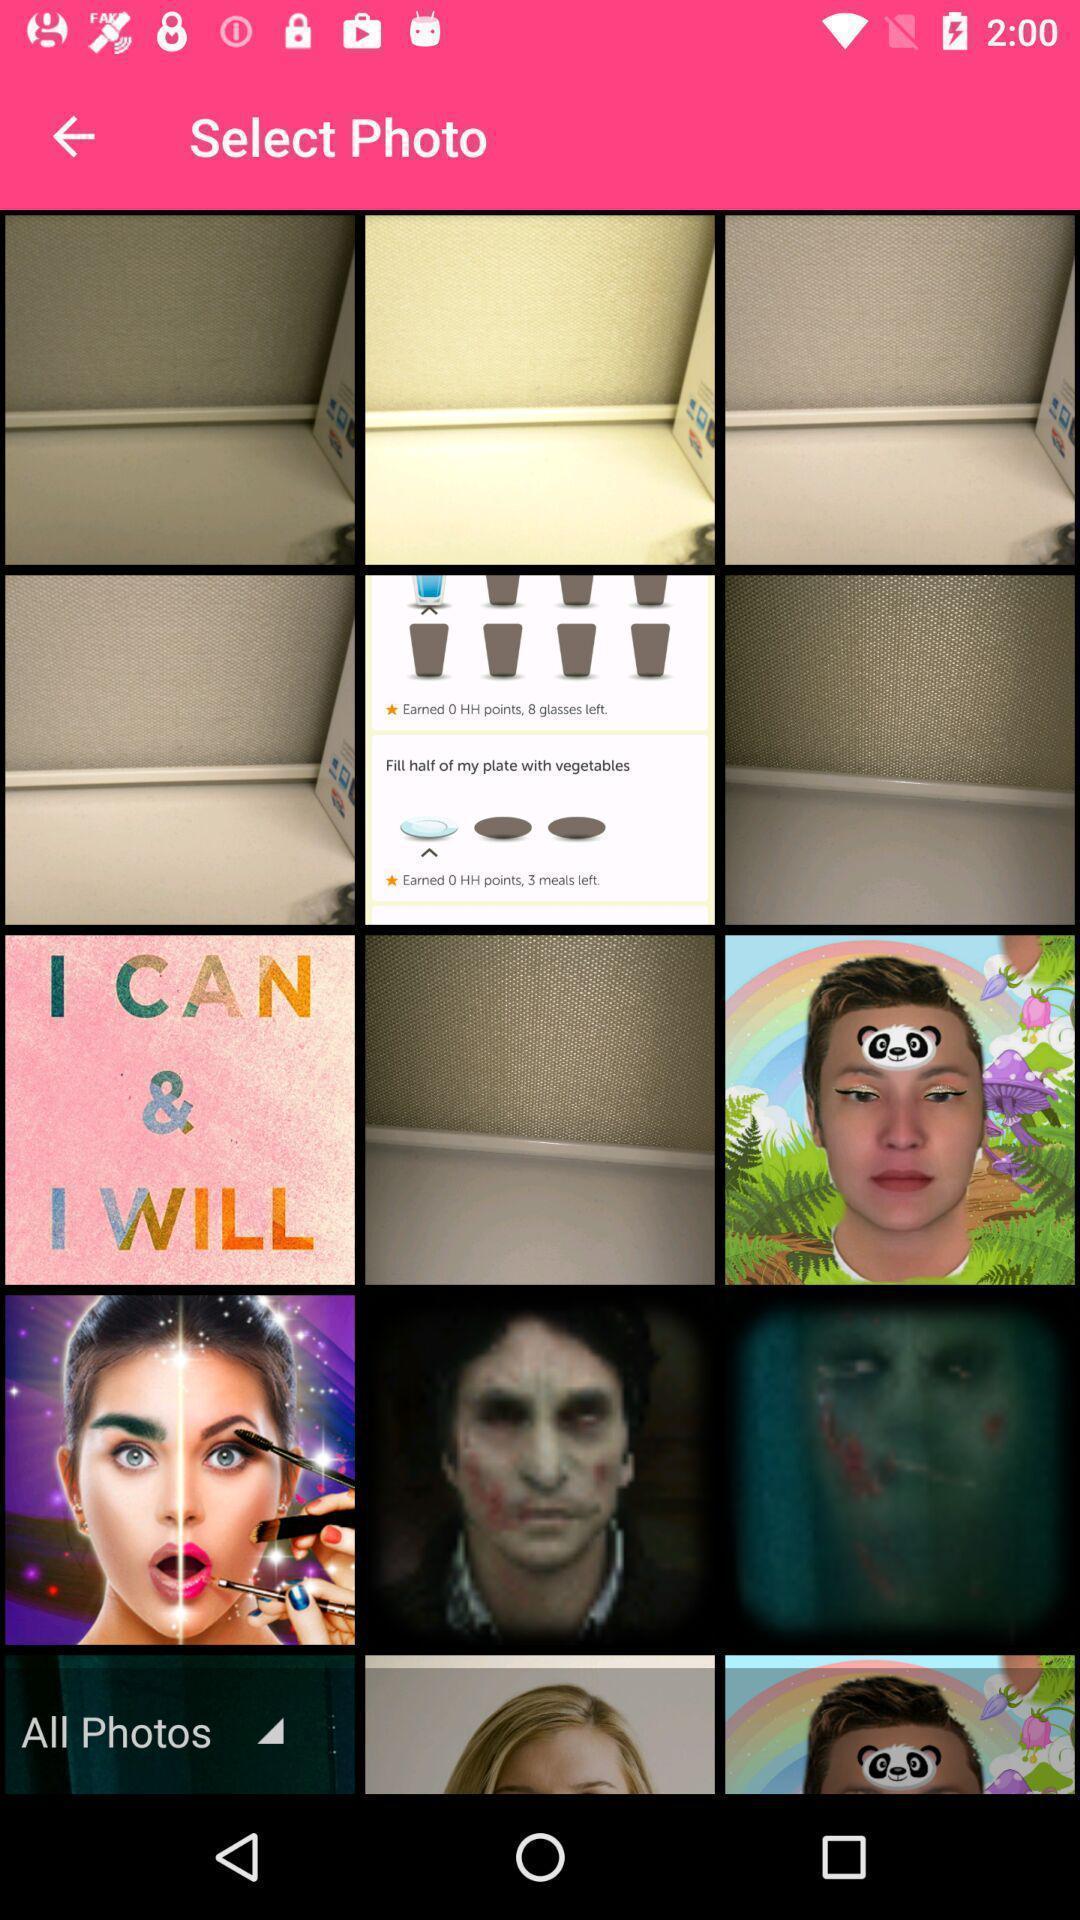What can you discern from this picture? Page showing different photos. 